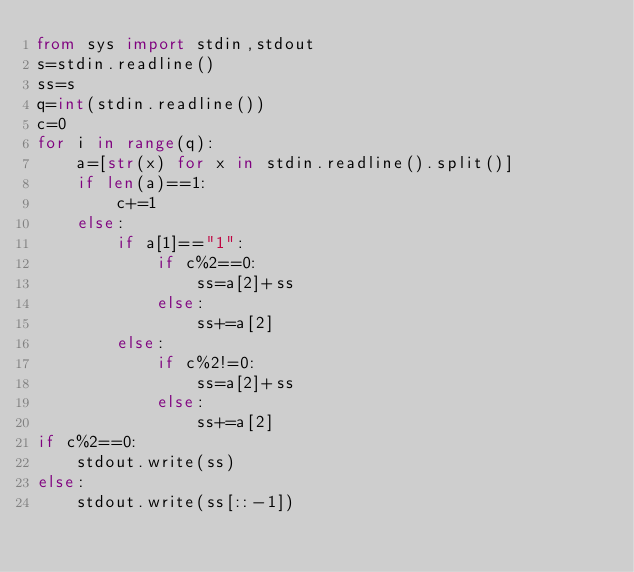<code> <loc_0><loc_0><loc_500><loc_500><_Python_>from sys import stdin,stdout
s=stdin.readline()
ss=s
q=int(stdin.readline())
c=0
for i in range(q):
    a=[str(x) for x in stdin.readline().split()]
    if len(a)==1:
        c+=1
    else:
        if a[1]=="1":
            if c%2==0:
                ss=a[2]+ss 
            else:
                ss+=a[2]
        else:
            if c%2!=0:
                ss=a[2]+ss 
            else:
                ss+=a[2] 
if c%2==0:
    stdout.write(ss)
else:
    stdout.write(ss[::-1])
        
            
            
            
        </code> 